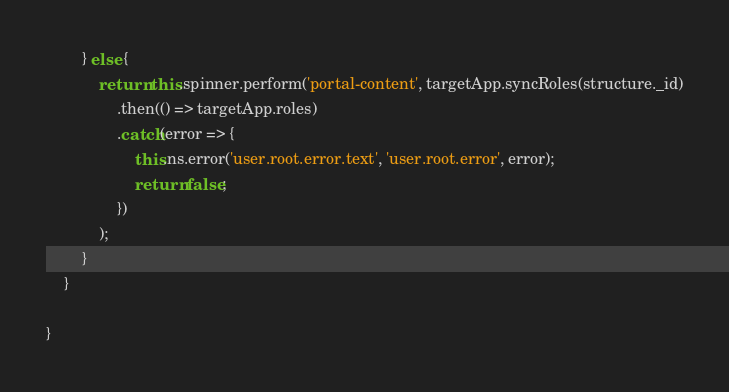<code> <loc_0><loc_0><loc_500><loc_500><_TypeScript_>        } else {
            return this.spinner.perform('portal-content', targetApp.syncRoles(structure._id)
                .then(() => targetApp.roles)
                .catch(error => {
                    this.ns.error('user.root.error.text', 'user.root.error', error);
                    return false;
                })
            );
        }
    }

}
</code> 